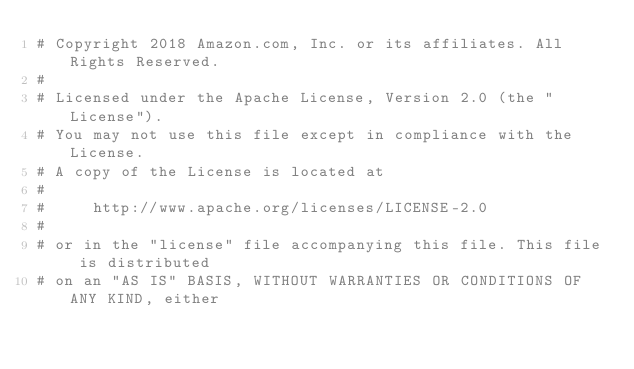Convert code to text. <code><loc_0><loc_0><loc_500><loc_500><_Python_># Copyright 2018 Amazon.com, Inc. or its affiliates. All Rights Reserved.
#
# Licensed under the Apache License, Version 2.0 (the "License").
# You may not use this file except in compliance with the License.
# A copy of the License is located at
#
#     http://www.apache.org/licenses/LICENSE-2.0
#
# or in the "license" file accompanying this file. This file is distributed
# on an "AS IS" BASIS, WITHOUT WARRANTIES OR CONDITIONS OF ANY KIND, either</code> 